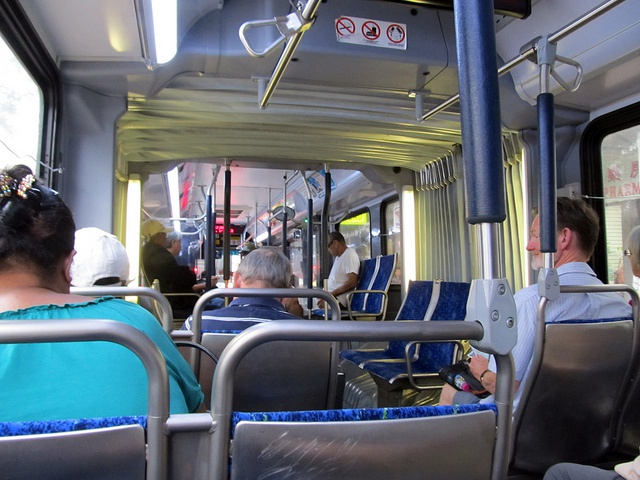Describe the objects in this image and their specific colors. I can see chair in black, gray, lightblue, and navy tones, people in black, lightblue, and gray tones, chair in black, gray, and darkgray tones, people in black, gray, and darkgray tones, and chair in black, gray, and navy tones in this image. 